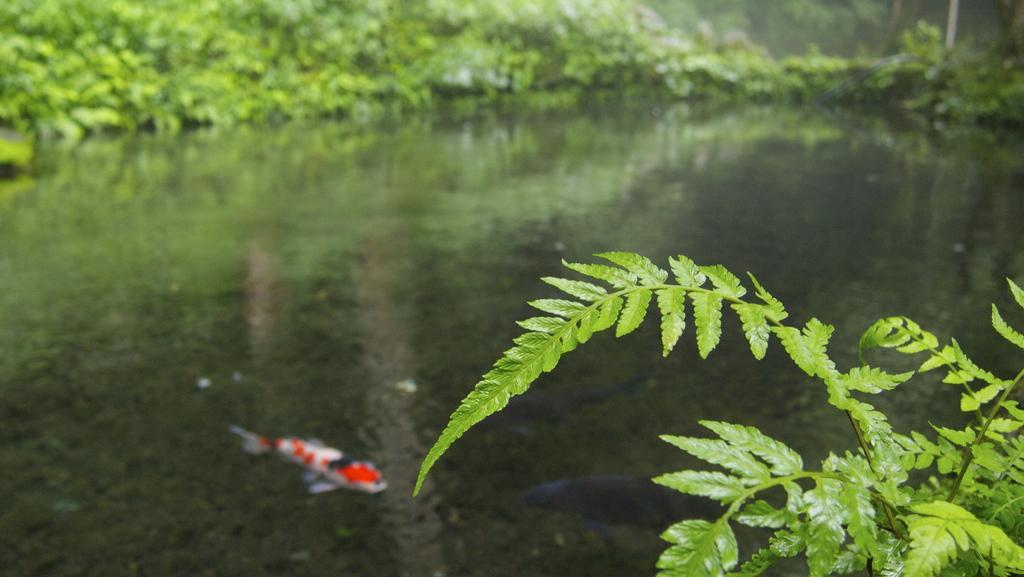Could you give a brief overview of what you see in this image? In the image we can see leaves, water and fish in the water, and the background is blurred. 